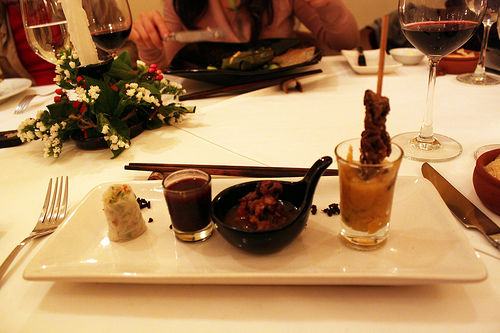<image>
Can you confirm if the chopsticks is on the plate? No. The chopsticks is not positioned on the plate. They may be near each other, but the chopsticks is not supported by or resting on top of the plate. Is the fork on the tray? No. The fork is not positioned on the tray. They may be near each other, but the fork is not supported by or resting on top of the tray. Is there a bowl on the plate? No. The bowl is not positioned on the plate. They may be near each other, but the bowl is not supported by or resting on top of the plate. 